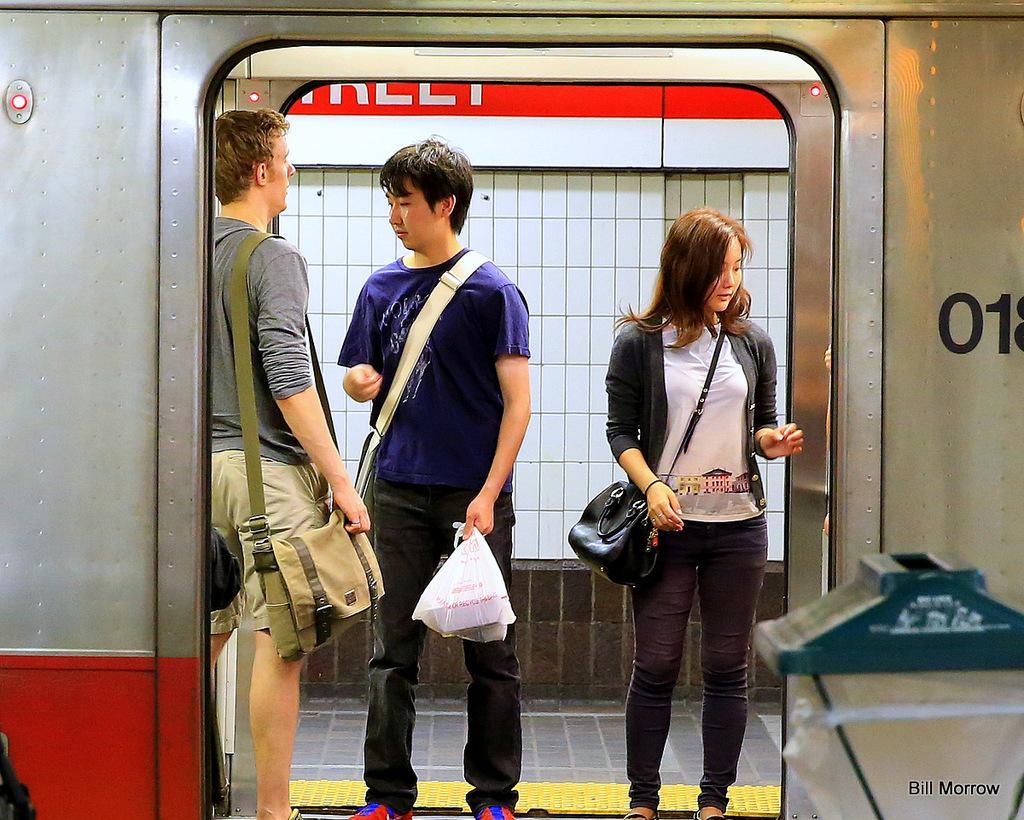Please provide a concise description of this image. In this image, In the middle there are some people standing and holding somethings in their hands, In the background there is a fence and there is a wall in white color. 